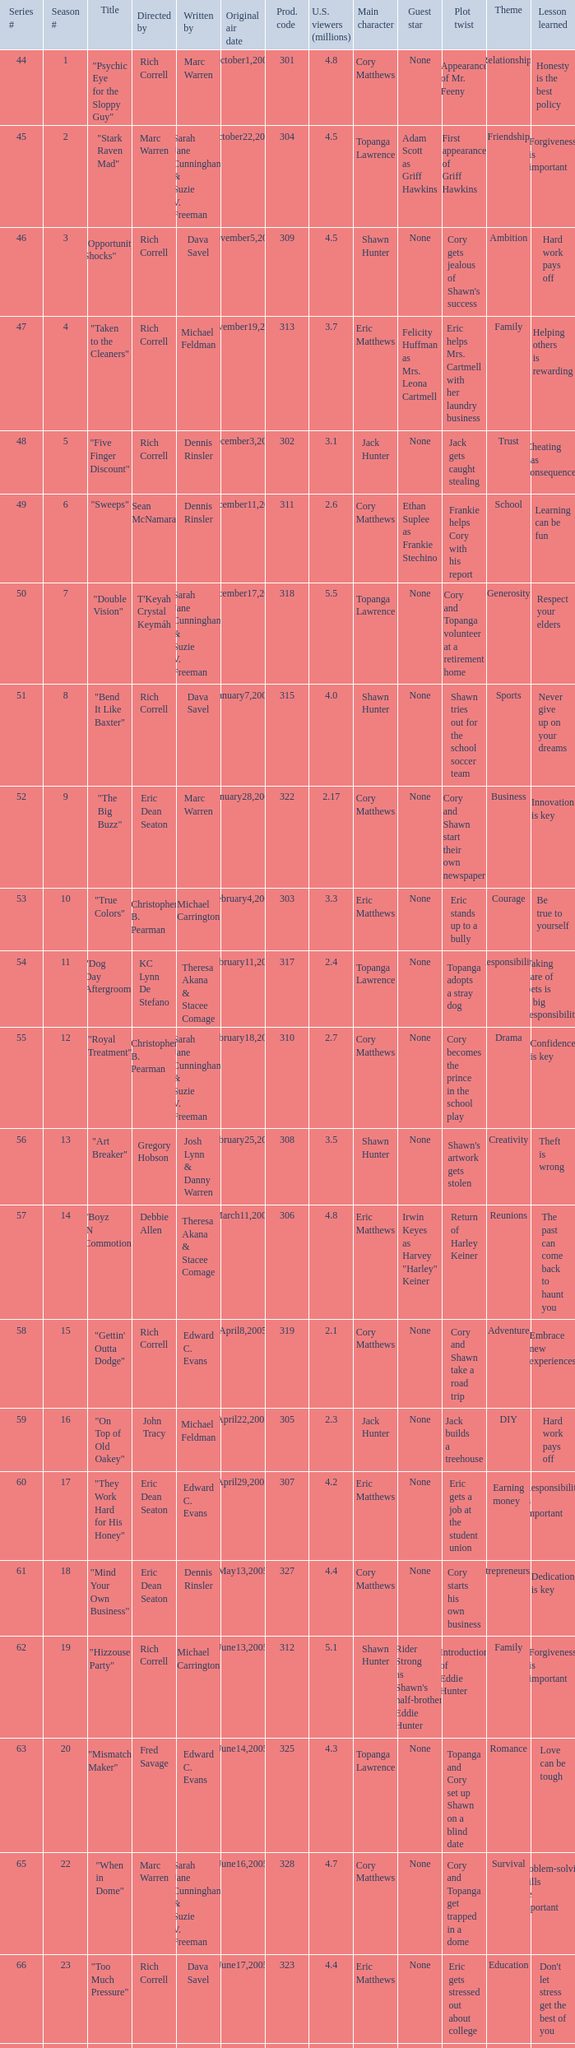What number episode in the season had a production code of 334? 32.0. 